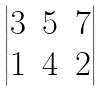<formula> <loc_0><loc_0><loc_500><loc_500>\begin{vmatrix} 3 & 5 & 7 \\ 1 & 4 & 2 \end{vmatrix}</formula> 